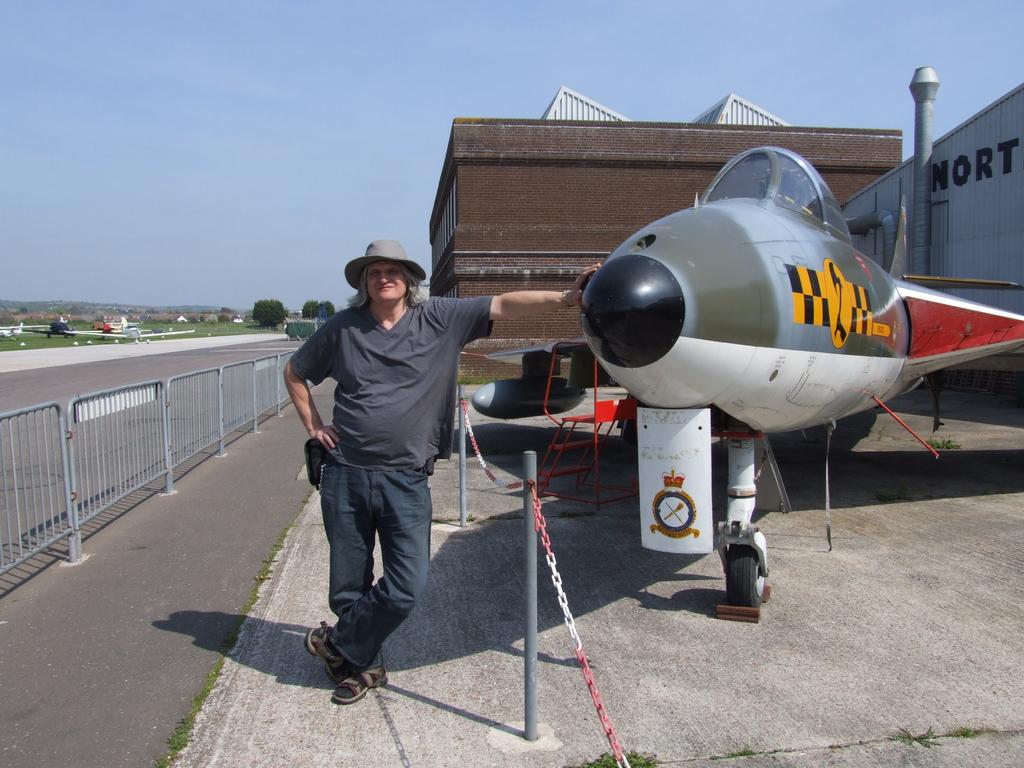What is written on the grey hanger?
Provide a short and direct response. Nort. 